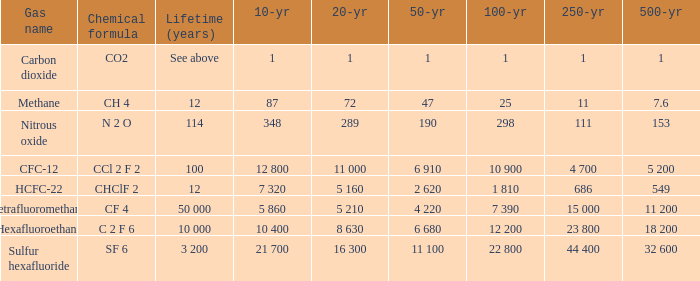What is the lifetime (years) for chemical formula ch 4? 12.0. 